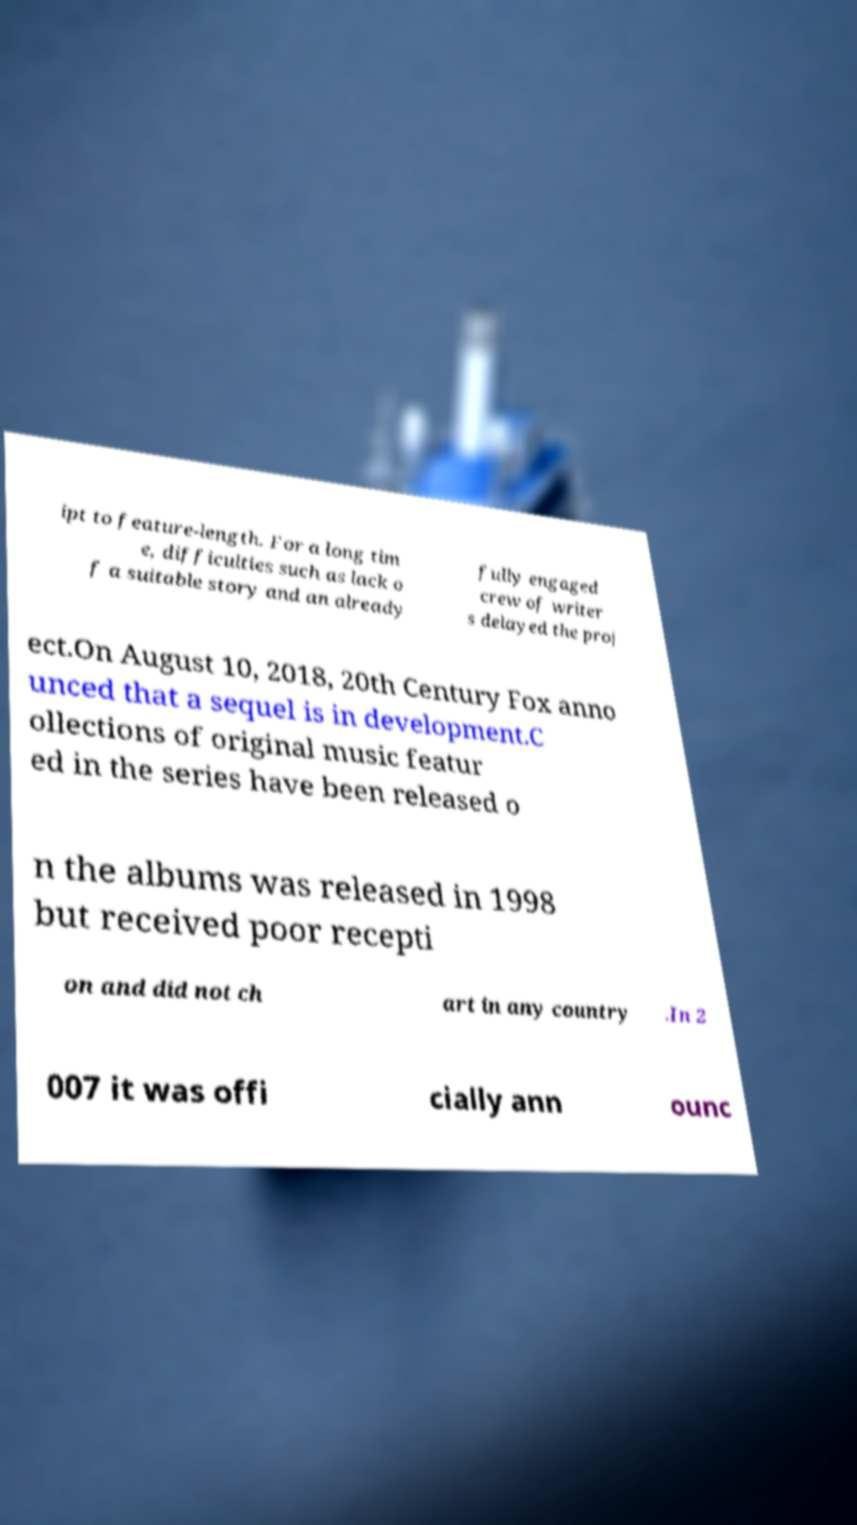Please identify and transcribe the text found in this image. ipt to feature-length. For a long tim e, difficulties such as lack o f a suitable story and an already fully engaged crew of writer s delayed the proj ect.On August 10, 2018, 20th Century Fox anno unced that a sequel is in development.C ollections of original music featur ed in the series have been released o n the albums was released in 1998 but received poor recepti on and did not ch art in any country .In 2 007 it was offi cially ann ounc 